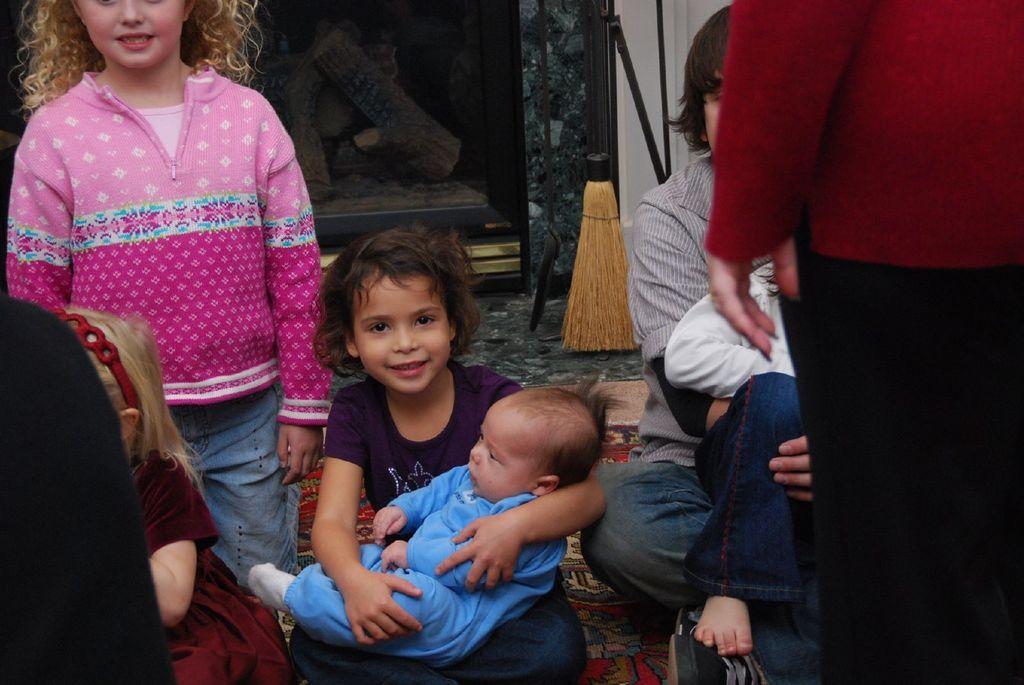Describe this image in one or two sentences. Here we can see few persons. She is holding a baby with her hands. This is floor. In the background we can see wooden oven. 